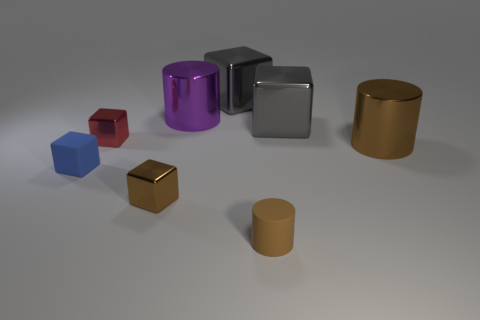Subtract all small matte cylinders. How many cylinders are left? 2 Add 1 blue rubber cylinders. How many objects exist? 9 Subtract 3 cubes. How many cubes are left? 2 Subtract all purple cylinders. How many cylinders are left? 2 Subtract all red cylinders. Subtract all cyan balls. How many cylinders are left? 3 Subtract all yellow spheres. How many cyan cylinders are left? 0 Subtract all small brown cylinders. Subtract all matte cubes. How many objects are left? 6 Add 5 big brown metal objects. How many big brown metal objects are left? 6 Add 1 big gray metal cubes. How many big gray metal cubes exist? 3 Subtract 1 brown cylinders. How many objects are left? 7 